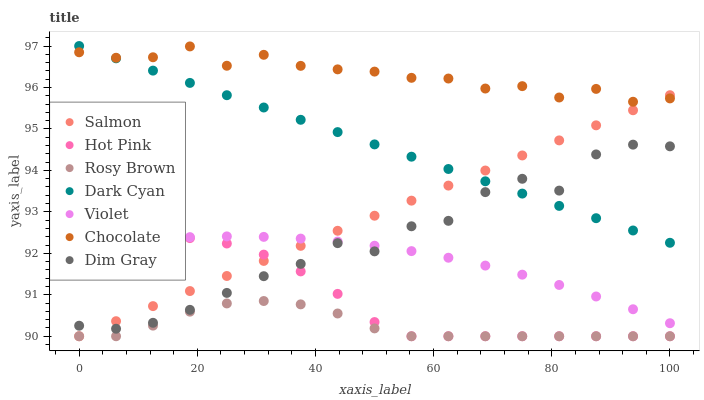Does Rosy Brown have the minimum area under the curve?
Answer yes or no. Yes. Does Chocolate have the maximum area under the curve?
Answer yes or no. Yes. Does Salmon have the minimum area under the curve?
Answer yes or no. No. Does Salmon have the maximum area under the curve?
Answer yes or no. No. Is Salmon the smoothest?
Answer yes or no. Yes. Is Dim Gray the roughest?
Answer yes or no. Yes. Is Rosy Brown the smoothest?
Answer yes or no. No. Is Rosy Brown the roughest?
Answer yes or no. No. Does Hot Pink have the lowest value?
Answer yes or no. Yes. Does Chocolate have the lowest value?
Answer yes or no. No. Does Dark Cyan have the highest value?
Answer yes or no. Yes. Does Salmon have the highest value?
Answer yes or no. No. Is Rosy Brown less than Violet?
Answer yes or no. Yes. Is Violet greater than Rosy Brown?
Answer yes or no. Yes. Does Salmon intersect Hot Pink?
Answer yes or no. Yes. Is Salmon less than Hot Pink?
Answer yes or no. No. Is Salmon greater than Hot Pink?
Answer yes or no. No. Does Rosy Brown intersect Violet?
Answer yes or no. No. 